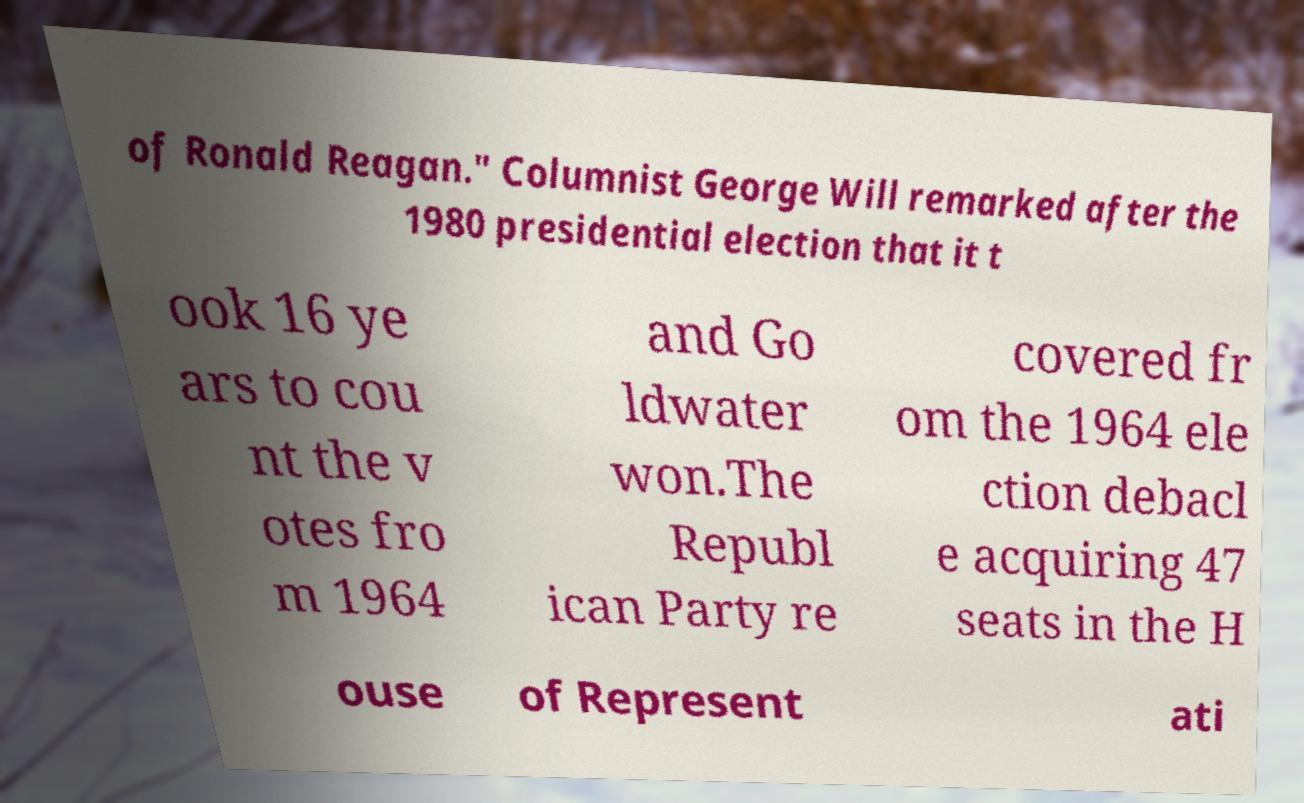There's text embedded in this image that I need extracted. Can you transcribe it verbatim? of Ronald Reagan." Columnist George Will remarked after the 1980 presidential election that it t ook 16 ye ars to cou nt the v otes fro m 1964 and Go ldwater won.The Republ ican Party re covered fr om the 1964 ele ction debacl e acquiring 47 seats in the H ouse of Represent ati 